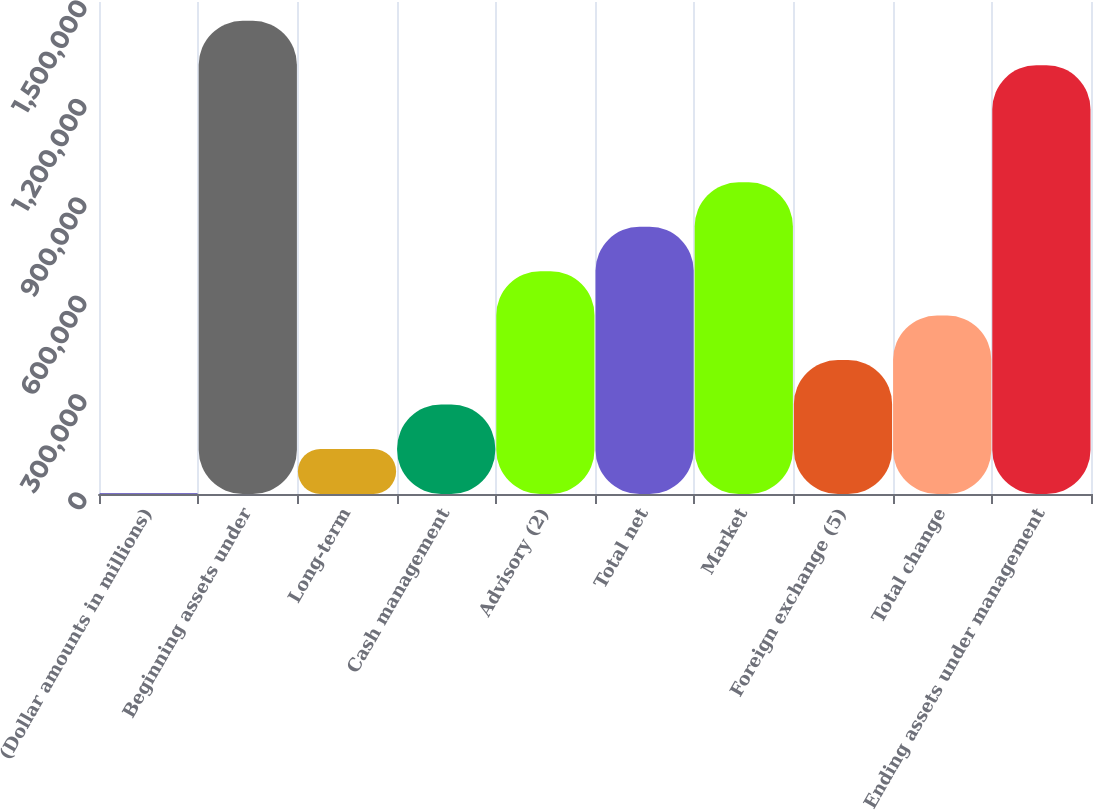Convert chart. <chart><loc_0><loc_0><loc_500><loc_500><bar_chart><fcel>(Dollar amounts in millions)<fcel>Beginning assets under<fcel>Long-term<fcel>Cash management<fcel>Advisory (2)<fcel>Total net<fcel>Market<fcel>Foreign exchange (5)<fcel>Total change<fcel>Ending assets under management<nl><fcel>2008<fcel>1.44261e+06<fcel>137472<fcel>272935<fcel>679326<fcel>814790<fcel>950253<fcel>408399<fcel>543862<fcel>1.30715e+06<nl></chart> 